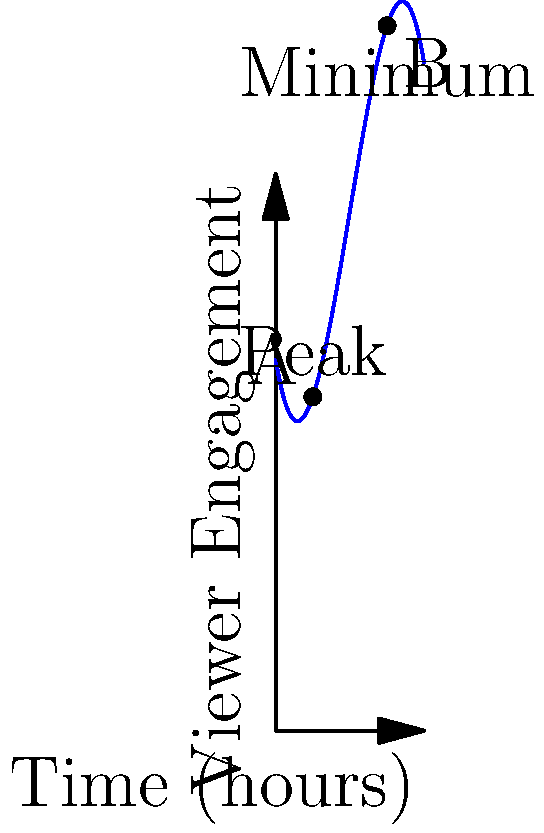Based on your experience in television programming, consider the following viewer engagement model for a new prime-time show. The function $f(x) = -0.25x^3 + 3x^2 - 6x + 20$ represents viewer engagement (in millions) over time, where $x$ is the number of hours since the show's start at 8 PM. What is the total change in viewer engagement from the show's peak to its minimum point during the 8-hour period shown? To solve this problem, we'll follow these steps:

1) First, we need to find the peak and minimum points of viewer engagement.

2) The peak and minimum occur where the derivative of the function is zero:
   $f'(x) = -0.75x^2 + 6x - 6$
   Setting this equal to zero: $-0.75x^2 + 6x - 6 = 0$

3) Solving this quadratic equation:
   $x = 2$ or $x = 6$

4) The peak occurs at $x = 2$ (2 hours after 8 PM, or 10 PM)
   The minimum occurs at $x = 6$ (6 hours after 8 PM, or 2 AM)

5) Calculate viewer engagement at peak (x = 2):
   $f(2) = -0.25(2)^3 + 3(2)^2 - 6(2) + 20 = 24$ million viewers

6) Calculate viewer engagement at minimum (x = 6):
   $f(6) = -0.25(6)^3 + 3(6)^2 - 6(6) + 20 = 2$ million viewers

7) Calculate the total change:
   Change = Peak - Minimum = 24 - 2 = 22 million viewers

Therefore, the total change in viewer engagement from the peak to the minimum is 22 million viewers.
Answer: 22 million viewers 